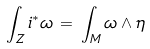<formula> <loc_0><loc_0><loc_500><loc_500>\int _ { Z } i ^ { * } \omega \, = \, \int _ { M } \omega \wedge \eta</formula> 